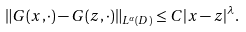Convert formula to latex. <formula><loc_0><loc_0><loc_500><loc_500>\| G ( x , \cdot ) - G ( z , \cdot ) \| _ { L ^ { \alpha } ( D ) } \leq C | x - z | ^ { \lambda } .</formula> 